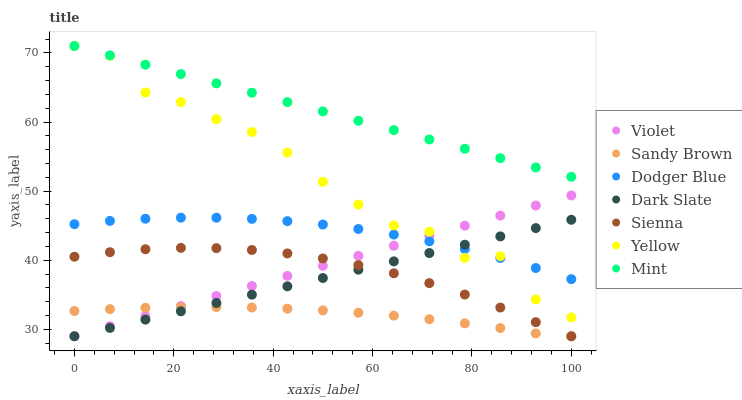Does Sandy Brown have the minimum area under the curve?
Answer yes or no. Yes. Does Mint have the maximum area under the curve?
Answer yes or no. Yes. Does Yellow have the minimum area under the curve?
Answer yes or no. No. Does Yellow have the maximum area under the curve?
Answer yes or no. No. Is Violet the smoothest?
Answer yes or no. Yes. Is Yellow the roughest?
Answer yes or no. Yes. Is Sienna the smoothest?
Answer yes or no. No. Is Sienna the roughest?
Answer yes or no. No. Does Sienna have the lowest value?
Answer yes or no. Yes. Does Yellow have the lowest value?
Answer yes or no. No. Does Yellow have the highest value?
Answer yes or no. Yes. Does Sienna have the highest value?
Answer yes or no. No. Is Sandy Brown less than Mint?
Answer yes or no. Yes. Is Mint greater than Dark Slate?
Answer yes or no. Yes. Does Dark Slate intersect Sandy Brown?
Answer yes or no. Yes. Is Dark Slate less than Sandy Brown?
Answer yes or no. No. Is Dark Slate greater than Sandy Brown?
Answer yes or no. No. Does Sandy Brown intersect Mint?
Answer yes or no. No. 